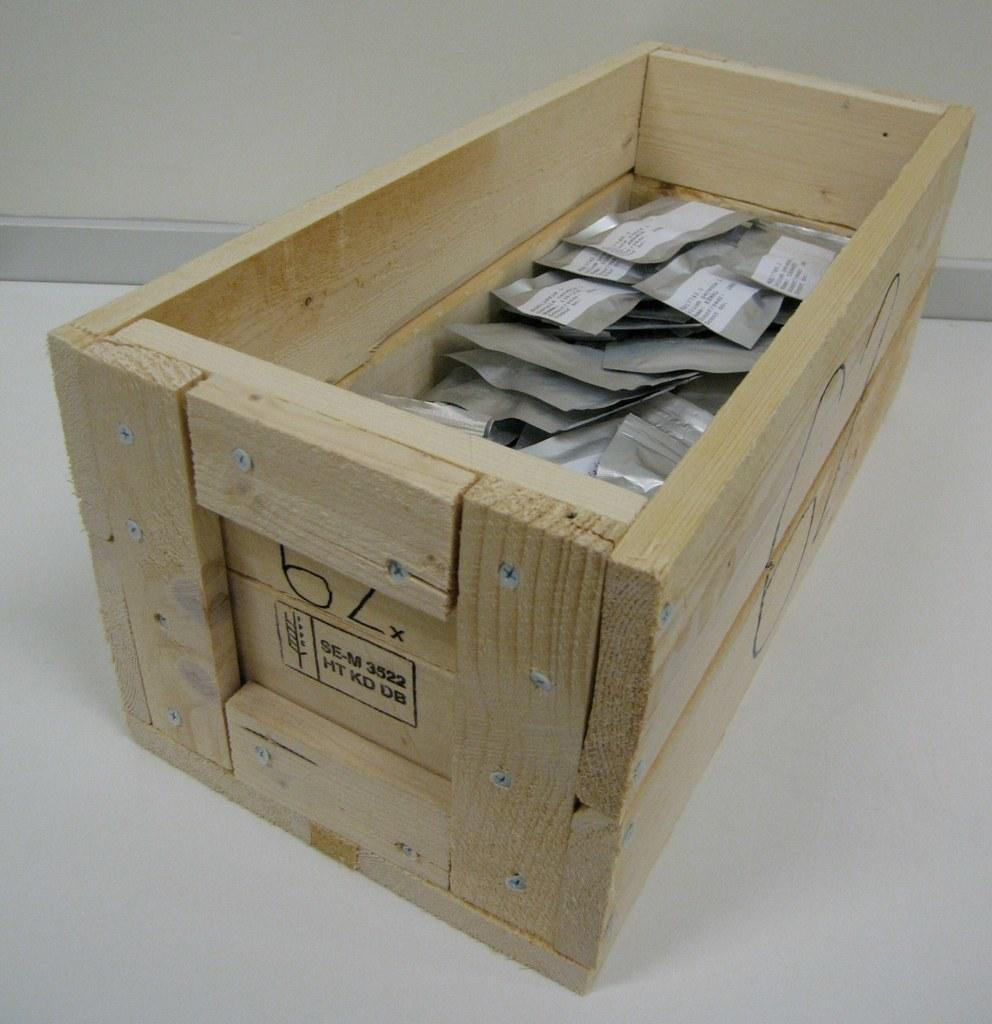<image>
Offer a succinct explanation of the picture presented. A box with packages inside with the letters SE-M HT KD DB on the side 